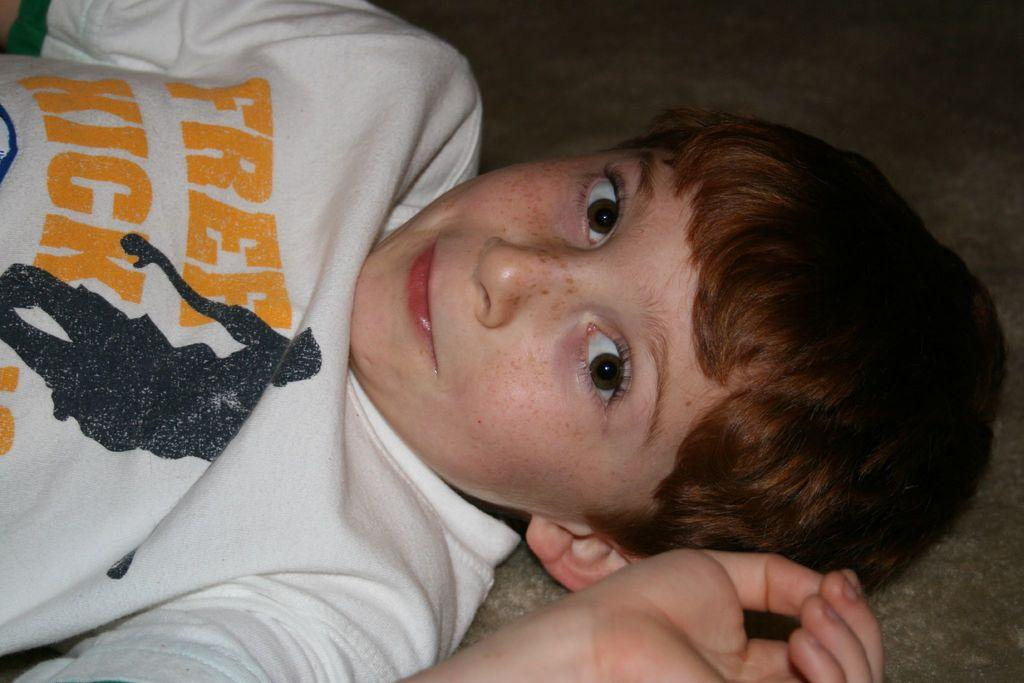Who or what is the main subject of the image? There is a person in the image. What is the person wearing? The person is wearing a white dress. What can be observed about the background of the image? The background of the image is dark. What type of secretary can be seen working in the image? There is no secretary present in the image; it features a person wearing a white dress with a dark background. 